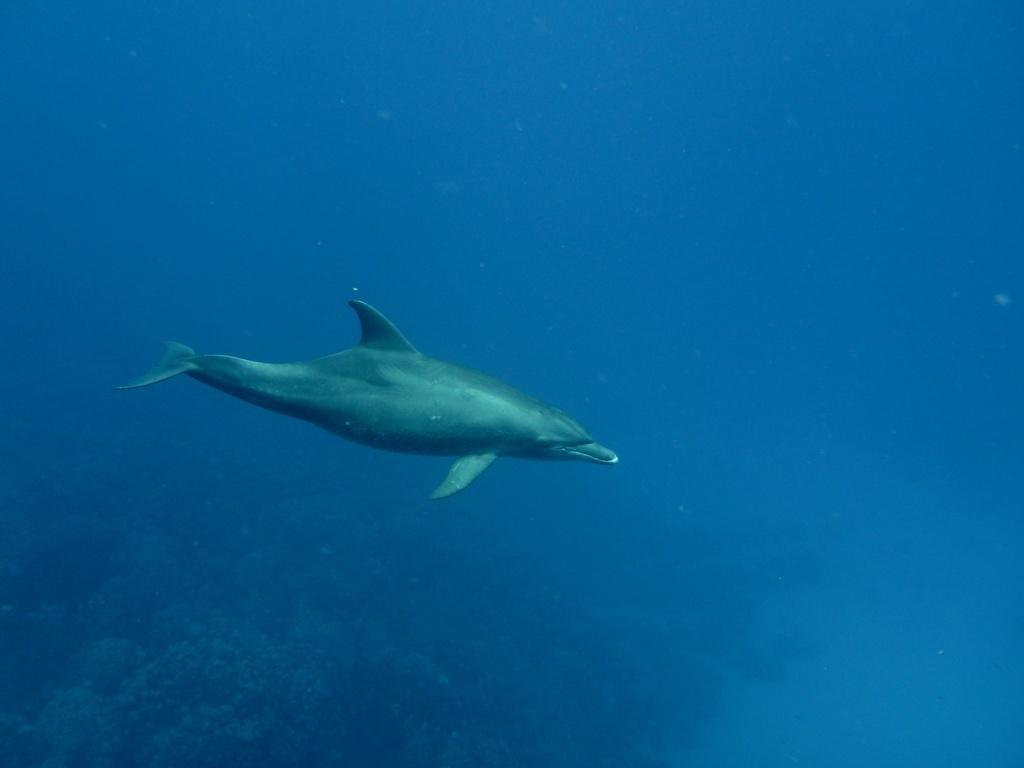What animal can be seen in the water in the image? There is a dolphin in the water in the image. What type of vegetation is on the left side of the image? There are plants on the left side of the image. How many boats are visible in the image during the rainstorm? There are no boats or rainstorm present in the image; it features a dolphin in the water and plants on the left side. 